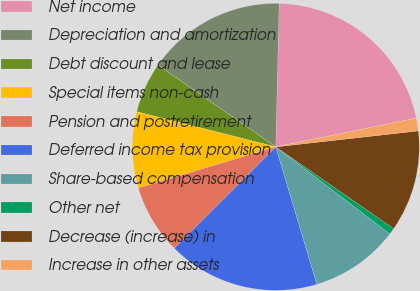<chart> <loc_0><loc_0><loc_500><loc_500><pie_chart><fcel>Net income<fcel>Depreciation and amortization<fcel>Debt discount and lease<fcel>Special items non-cash<fcel>Pension and postretirement<fcel>Deferred income tax provision<fcel>Share-based compensation<fcel>Other net<fcel>Decrease (increase) in<fcel>Increase in other assets<nl><fcel>21.42%<fcel>15.71%<fcel>5.72%<fcel>8.57%<fcel>7.86%<fcel>17.14%<fcel>10.0%<fcel>0.72%<fcel>11.43%<fcel>1.43%<nl></chart> 